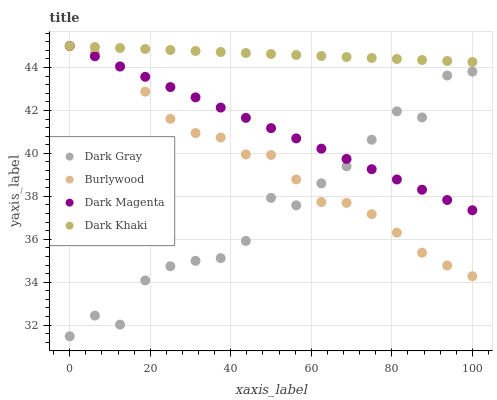Does Dark Gray have the minimum area under the curve?
Answer yes or no. Yes. Does Dark Khaki have the maximum area under the curve?
Answer yes or no. Yes. Does Burlywood have the minimum area under the curve?
Answer yes or no. No. Does Burlywood have the maximum area under the curve?
Answer yes or no. No. Is Dark Khaki the smoothest?
Answer yes or no. Yes. Is Dark Gray the roughest?
Answer yes or no. Yes. Is Burlywood the smoothest?
Answer yes or no. No. Is Burlywood the roughest?
Answer yes or no. No. Does Dark Gray have the lowest value?
Answer yes or no. Yes. Does Burlywood have the lowest value?
Answer yes or no. No. Does Dark Magenta have the highest value?
Answer yes or no. Yes. Is Dark Gray less than Dark Khaki?
Answer yes or no. Yes. Is Dark Khaki greater than Dark Gray?
Answer yes or no. Yes. Does Dark Gray intersect Burlywood?
Answer yes or no. Yes. Is Dark Gray less than Burlywood?
Answer yes or no. No. Is Dark Gray greater than Burlywood?
Answer yes or no. No. Does Dark Gray intersect Dark Khaki?
Answer yes or no. No. 